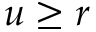Convert formula to latex. <formula><loc_0><loc_0><loc_500><loc_500>u \geq r</formula> 